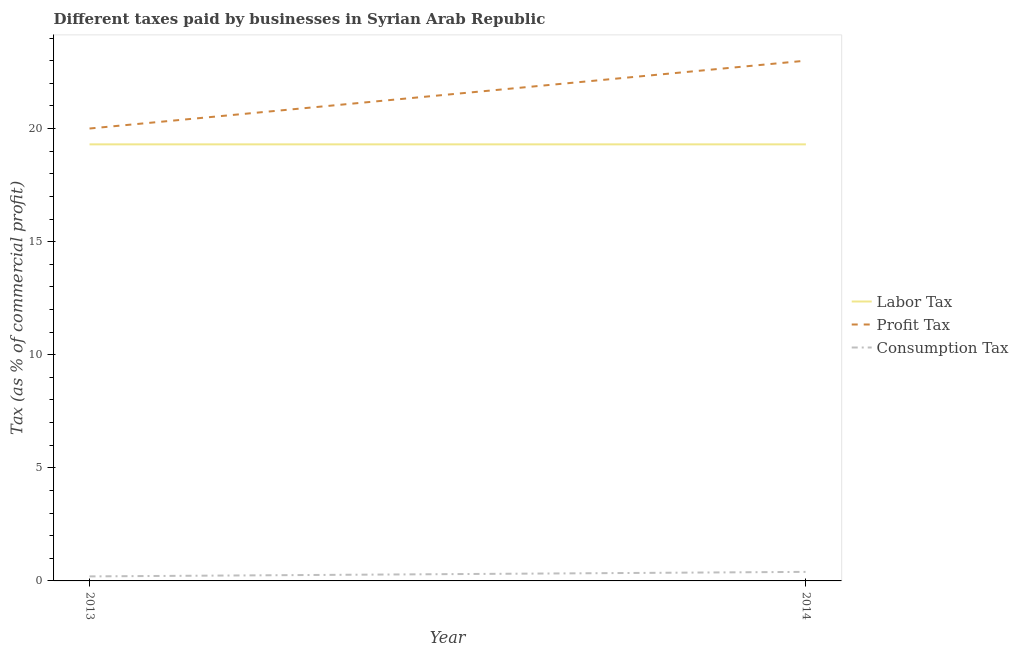Is the number of lines equal to the number of legend labels?
Your answer should be very brief. Yes. What is the percentage of profit tax in 2013?
Offer a terse response. 20. Across all years, what is the maximum percentage of consumption tax?
Your answer should be compact. 0.4. Across all years, what is the minimum percentage of profit tax?
Provide a succinct answer. 20. In which year was the percentage of profit tax minimum?
Offer a terse response. 2013. What is the total percentage of consumption tax in the graph?
Keep it short and to the point. 0.6. What is the difference between the percentage of profit tax in 2013 and that in 2014?
Offer a terse response. -3. What is the difference between the percentage of consumption tax in 2013 and the percentage of labor tax in 2014?
Offer a very short reply. -19.1. What is the average percentage of consumption tax per year?
Make the answer very short. 0.3. In the year 2014, what is the difference between the percentage of labor tax and percentage of profit tax?
Make the answer very short. -3.7. Does the percentage of profit tax monotonically increase over the years?
Offer a terse response. Yes. Is the percentage of consumption tax strictly greater than the percentage of profit tax over the years?
Make the answer very short. No. How many years are there in the graph?
Your answer should be very brief. 2. Are the values on the major ticks of Y-axis written in scientific E-notation?
Give a very brief answer. No. Does the graph contain grids?
Offer a terse response. No. How are the legend labels stacked?
Make the answer very short. Vertical. What is the title of the graph?
Provide a succinct answer. Different taxes paid by businesses in Syrian Arab Republic. Does "Central government" appear as one of the legend labels in the graph?
Your response must be concise. No. What is the label or title of the X-axis?
Provide a short and direct response. Year. What is the label or title of the Y-axis?
Provide a short and direct response. Tax (as % of commercial profit). What is the Tax (as % of commercial profit) in Labor Tax in 2013?
Your response must be concise. 19.3. What is the Tax (as % of commercial profit) in Consumption Tax in 2013?
Give a very brief answer. 0.2. What is the Tax (as % of commercial profit) of Labor Tax in 2014?
Make the answer very short. 19.3. What is the Tax (as % of commercial profit) in Consumption Tax in 2014?
Your answer should be very brief. 0.4. Across all years, what is the maximum Tax (as % of commercial profit) in Labor Tax?
Provide a short and direct response. 19.3. Across all years, what is the minimum Tax (as % of commercial profit) in Labor Tax?
Your response must be concise. 19.3. What is the total Tax (as % of commercial profit) of Labor Tax in the graph?
Offer a terse response. 38.6. What is the total Tax (as % of commercial profit) in Profit Tax in the graph?
Keep it short and to the point. 43. What is the total Tax (as % of commercial profit) in Consumption Tax in the graph?
Make the answer very short. 0.6. What is the difference between the Tax (as % of commercial profit) in Labor Tax in 2013 and that in 2014?
Provide a short and direct response. 0. What is the difference between the Tax (as % of commercial profit) of Consumption Tax in 2013 and that in 2014?
Your answer should be compact. -0.2. What is the difference between the Tax (as % of commercial profit) in Labor Tax in 2013 and the Tax (as % of commercial profit) in Profit Tax in 2014?
Your answer should be very brief. -3.7. What is the difference between the Tax (as % of commercial profit) in Profit Tax in 2013 and the Tax (as % of commercial profit) in Consumption Tax in 2014?
Ensure brevity in your answer.  19.6. What is the average Tax (as % of commercial profit) in Labor Tax per year?
Make the answer very short. 19.3. What is the average Tax (as % of commercial profit) of Profit Tax per year?
Offer a very short reply. 21.5. What is the average Tax (as % of commercial profit) of Consumption Tax per year?
Provide a short and direct response. 0.3. In the year 2013, what is the difference between the Tax (as % of commercial profit) of Labor Tax and Tax (as % of commercial profit) of Consumption Tax?
Provide a succinct answer. 19.1. In the year 2013, what is the difference between the Tax (as % of commercial profit) in Profit Tax and Tax (as % of commercial profit) in Consumption Tax?
Keep it short and to the point. 19.8. In the year 2014, what is the difference between the Tax (as % of commercial profit) of Labor Tax and Tax (as % of commercial profit) of Consumption Tax?
Your answer should be compact. 18.9. In the year 2014, what is the difference between the Tax (as % of commercial profit) of Profit Tax and Tax (as % of commercial profit) of Consumption Tax?
Offer a terse response. 22.6. What is the ratio of the Tax (as % of commercial profit) in Profit Tax in 2013 to that in 2014?
Your answer should be compact. 0.87. What is the ratio of the Tax (as % of commercial profit) in Consumption Tax in 2013 to that in 2014?
Your response must be concise. 0.5. What is the difference between the highest and the lowest Tax (as % of commercial profit) in Labor Tax?
Provide a succinct answer. 0. What is the difference between the highest and the lowest Tax (as % of commercial profit) of Consumption Tax?
Make the answer very short. 0.2. 